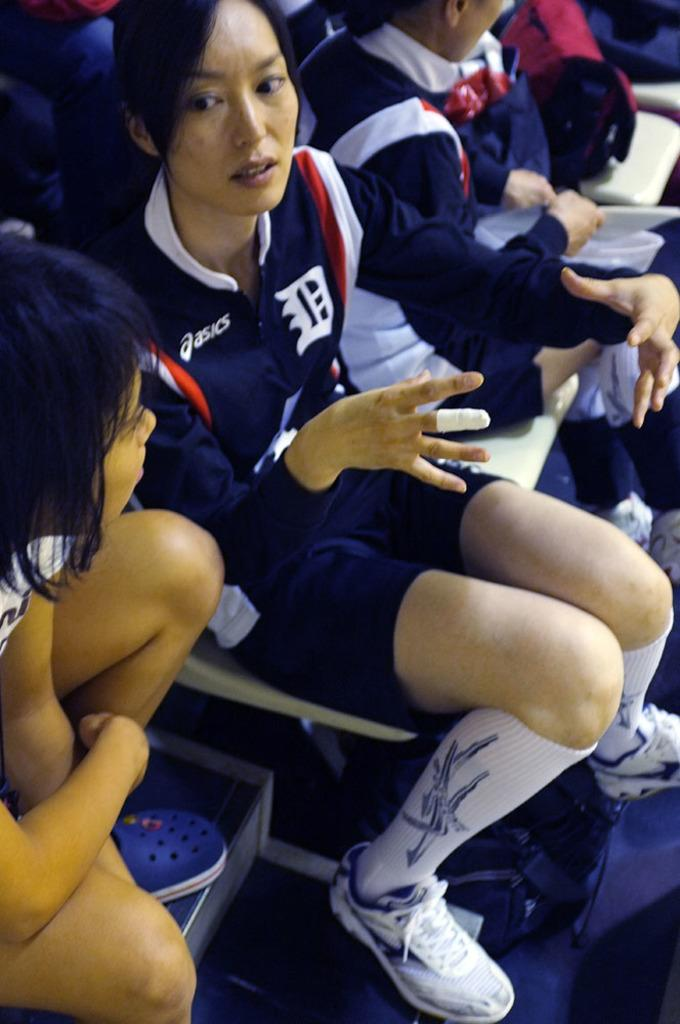<image>
Render a clear and concise summary of the photo. A female player wearing a blue Asics shirt 